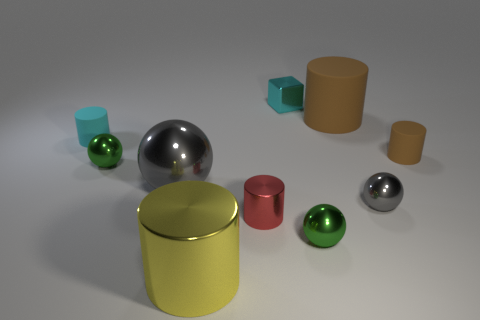Subtract all cyan cylinders. How many cylinders are left? 4 Subtract all large metal cylinders. How many cylinders are left? 4 Subtract all brown spheres. Subtract all brown blocks. How many spheres are left? 4 Subtract all blocks. How many objects are left? 9 Subtract all big yellow metal things. Subtract all tiny cyan shiny blocks. How many objects are left? 8 Add 1 cyan metal cubes. How many cyan metal cubes are left? 2 Add 7 big green shiny cylinders. How many big green shiny cylinders exist? 7 Subtract 0 green cubes. How many objects are left? 10 